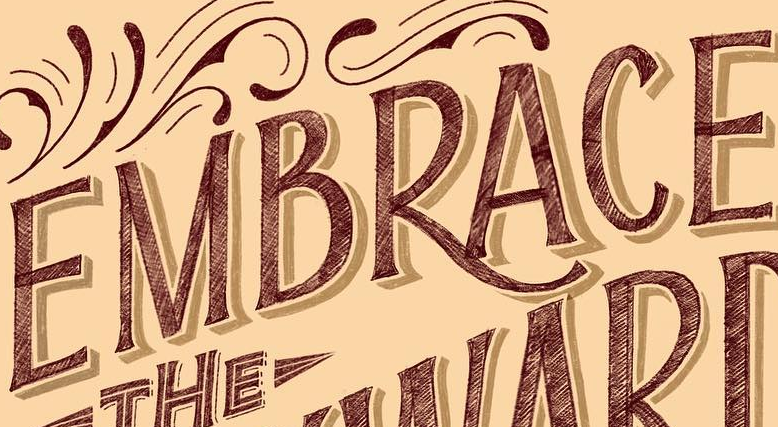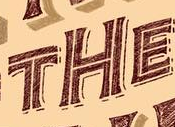What text appears in these images from left to right, separated by a semicolon? EMBRACE; THE 